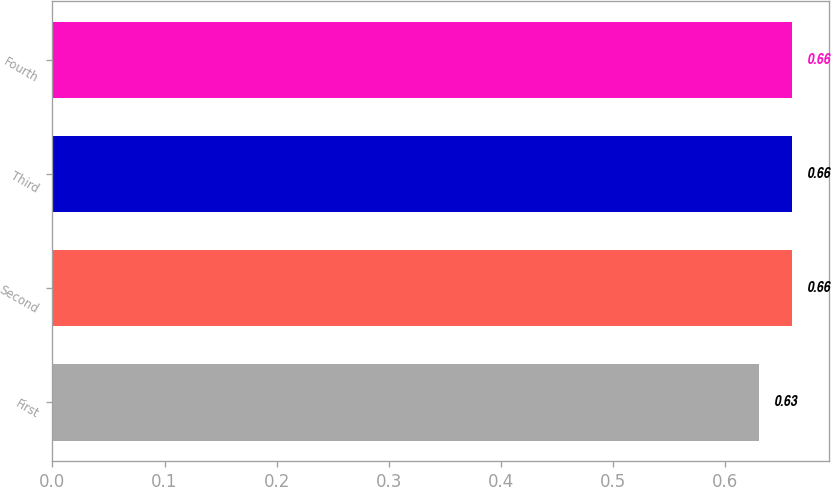<chart> <loc_0><loc_0><loc_500><loc_500><bar_chart><fcel>First<fcel>Second<fcel>Third<fcel>Fourth<nl><fcel>0.63<fcel>0.66<fcel>0.66<fcel>0.66<nl></chart> 